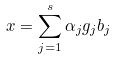Convert formula to latex. <formula><loc_0><loc_0><loc_500><loc_500>x = \sum _ { j = 1 } ^ { s } \alpha _ { j } g _ { j } b _ { j }</formula> 